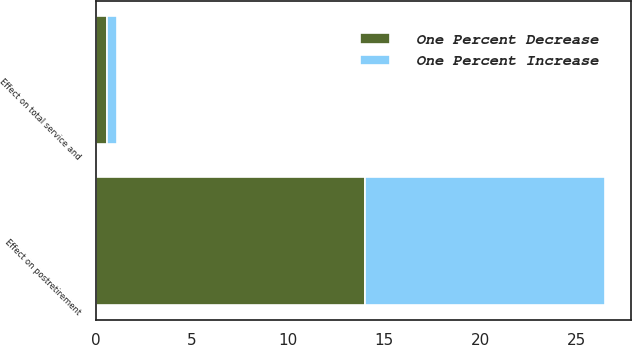Convert chart. <chart><loc_0><loc_0><loc_500><loc_500><stacked_bar_chart><ecel><fcel>Effect on total service and<fcel>Effect on postretirement<nl><fcel>One Percent Decrease<fcel>0.6<fcel>14<nl><fcel>One Percent Increase<fcel>0.5<fcel>12.5<nl></chart> 